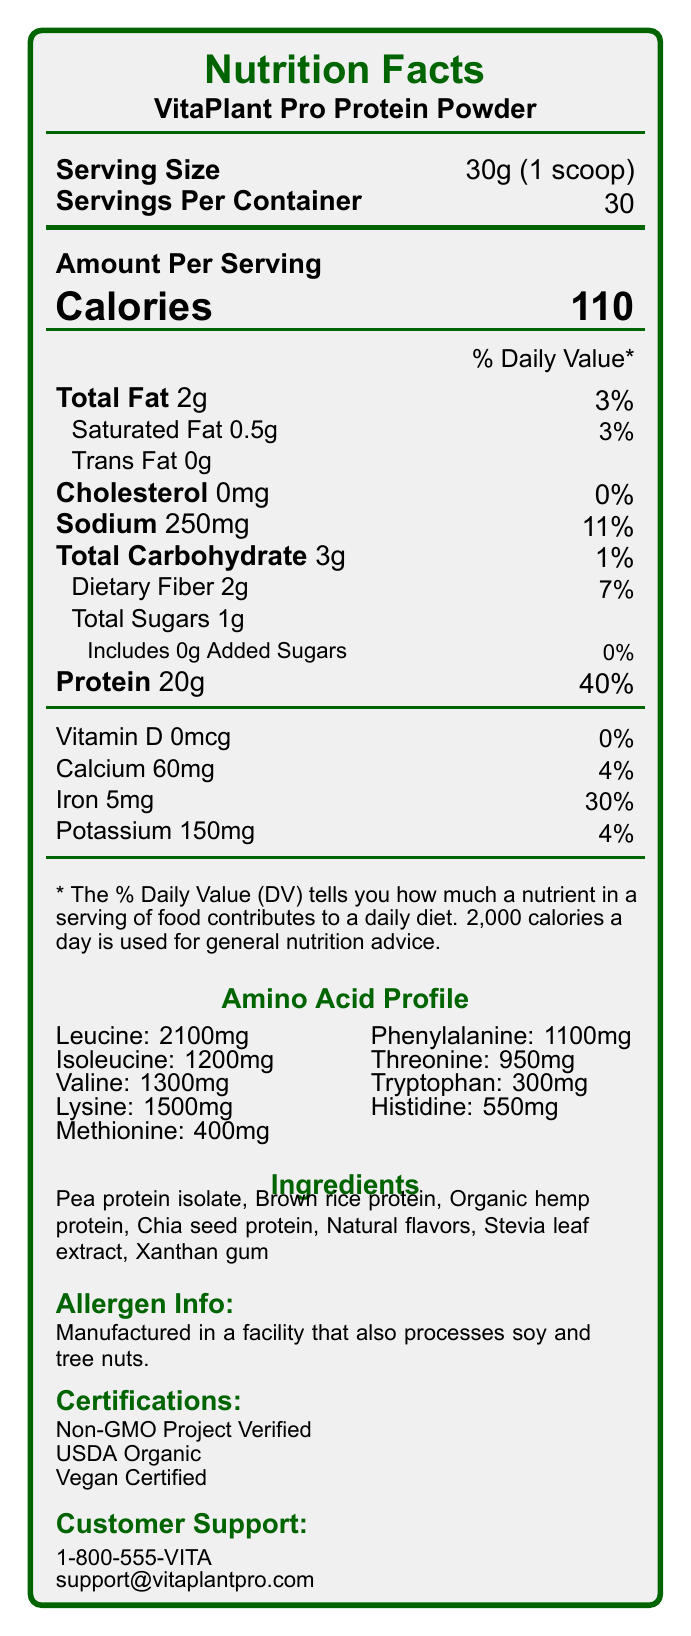what is the product name? The product name is clearly stated at the top of the document under the 'Nutrition Facts' heading.
Answer: VitaPlant Pro Protein Powder what is the serving size of VitaPlant Pro Protein Powder? The serving size is listed under the 'Serving Size' section as '30g (1 scoop)'.
Answer: 30g (1 scoop) how many calories are there per serving? The 'Calories' section shows that each serving contains 110 calories.
Answer: 110 what is the amount of sodium per serving, and what is its percentage of the daily value? The 'Sodium' section lists the amount as 250mg and the daily value percentage as 11%.
Answer: 250mg, 11% what types of protein are included in the ingredients? The 'Ingredients' section lists these types of protein.
Answer: Pea protein isolate, Brown rice protein, Organic hemp protein, Chia seed protein what are the calories per serving? Each serving contains 110 calories as shown in the 'Amount Per Serving' portion of the label.
Answer: 110 what is the total carbohydrate amount per serving, and what is the daily value percentage? The 'Total Carbohydrate' section lists 3g of carbohydrates and a daily value of 1%.
Answer: 3g, 1% what is the shelf life of the product? The 'Shelf Life' note indicates that the product lasts 18 months from its manufacture date.
Answer: 18 months from date of manufacture which certifications does this product have? The 'Certifications' section lists these three certifications.
Answer: Non-GMO Project Verified, USDA Organic, Vegan Certified how much protein does each serving contain? The 'Protein' section shows each serving contains 20g of protein.
Answer: 20g which amino acid has the highest amount in the profile? A. Leucine B. Isoleucine C. Lysine Leucine has the highest amount in the amino acid profile with 2100mg.
Answer: A. Leucine what is the serving size? A. 20g  B. 10g  C. 30g The serving size is 30g as mentioned in the 'Serving Size' section.
Answer: C. 30g how many servings are there per container? A. 25 B. 30  C. 35  D. 40 The 'Servings Per Container' section shows there are 30 servings per container.
Answer: B. 30 does the product contain any added sugars? The 'Added Sugars' section indicates '0g' added sugars, showing that no added sugars are present.
Answer: No is the product dairy-free? The product is certified vegan and contains only plant-based proteins, implying that it is dairy-free.
Answer: Yes please summarize the main features and benefits of VitaPlant Pro Protein Powder. This summary synthesizes the primary features and benefits, emphasizing its complete amino acid profile, certifications, and allergen information.
Answer: VitaPlant Pro Protein Powder is a plant-based protein supplement providing 20g of protein per serving. It has a complete amino acid profile detailed on the label. The product emphasizes muscle growth and recovery through amino acids like leucine, isoleucine, and valine. It is easily digestible and contains no artificial sweeteners or preservatives. It’s certified as Non-GMO, USDA Organic, and Vegan. It is allergen-friendly, though manufactured in a facility that processes soy and tree nuts. The product offers multiple flavor options and container sizes with a shelf life of 18 months. what are the directions for using the VitaPlant Pro Protein Powder? The 'Directions' section provides these instructions for use.
Answer: Mix one scoop (30g) with 8-10 oz of cold water or your favorite plant-based milk. Shake well and enjoy! what are the storage instructions for this product? The 'Storage Instructions' section provides this guidance.
Answer: Store in a cool, dry place. Seal bag tightly after opening. what is the amount of vitamin D in the product? The 'Vitamin D' section lists the amount as 0mcg.
Answer: 0mcg how much fat is in each serving, and how much of it is saturated fat? The 'Total Fat' section specifies 2g of total fat, and the 'Saturated Fat' component lists 0.5g.
Answer: 2g of total fat, 0.5g of saturated fat does the product include artificial sweeteners? The document states that the product contains only natural flavors and Stevia leaf extract, and emphasizes no artificial sweeteners or preservatives.
Answer: No do the instructions indicate how much liquid to mix with one scoop of the protein powder? The 'Directions' section advises mixing one scoop with 8-10 oz of liquid.
Answer: Yes, 8-10 oz what is the contact email for customer support? The 'Customer Support' section lists the email as support@vitaplantpro.com.
Answer: support@vitaplantpro.com which ingredient is not included in the list? A. Stevia leaf extract  B. Xanthan gum  C. Soy  D. Brown rice protein The ingredient list does not include soy, though it mentions being processed in a facility that handles soy.
Answer: C. Soy describe the amino acid profile featured on the product label. The profile lists the quantities of essential amino acids per serving, emphasizing the nutritional completeness.
Answer: The amino acid profile includes key amino acids such as leucine (2100mg), isoleucine (1200mg), valine (1300mg), lysine (1500mg), methionine (400mg), phenylalanine (1100mg), threonine (950mg), tryptophan (300mg), and histidine (550mg). 